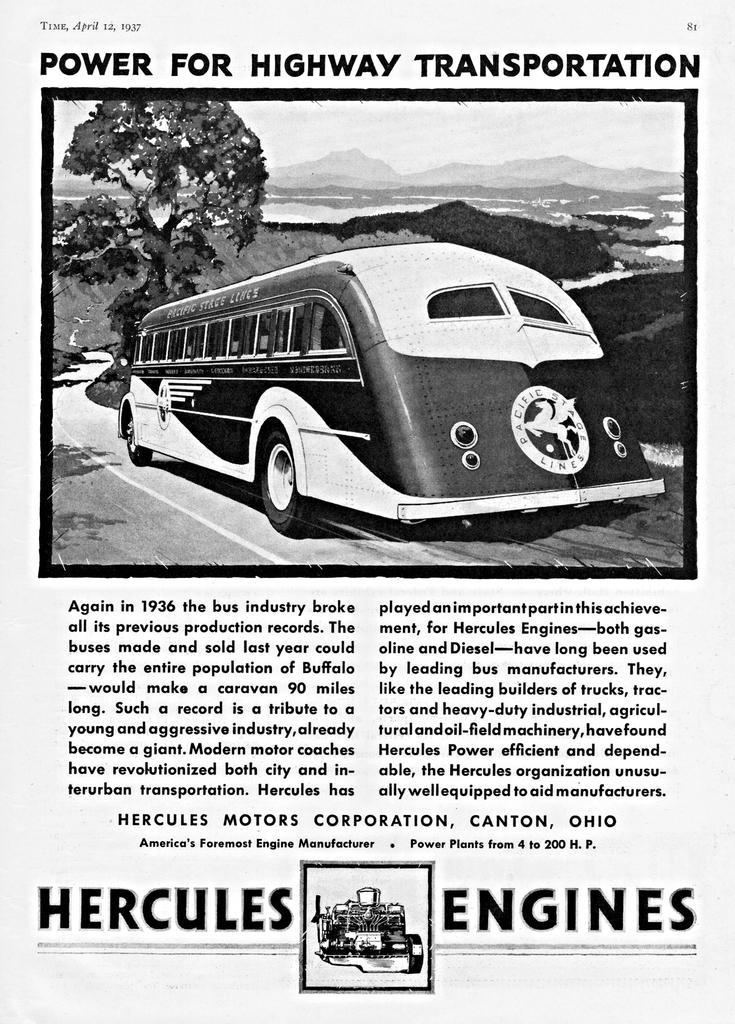How would you summarize this image in a sentence or two? In this image there is a paper and we can see a picture of a bus, tree, mountains and sky printed on the paper. There is text. 